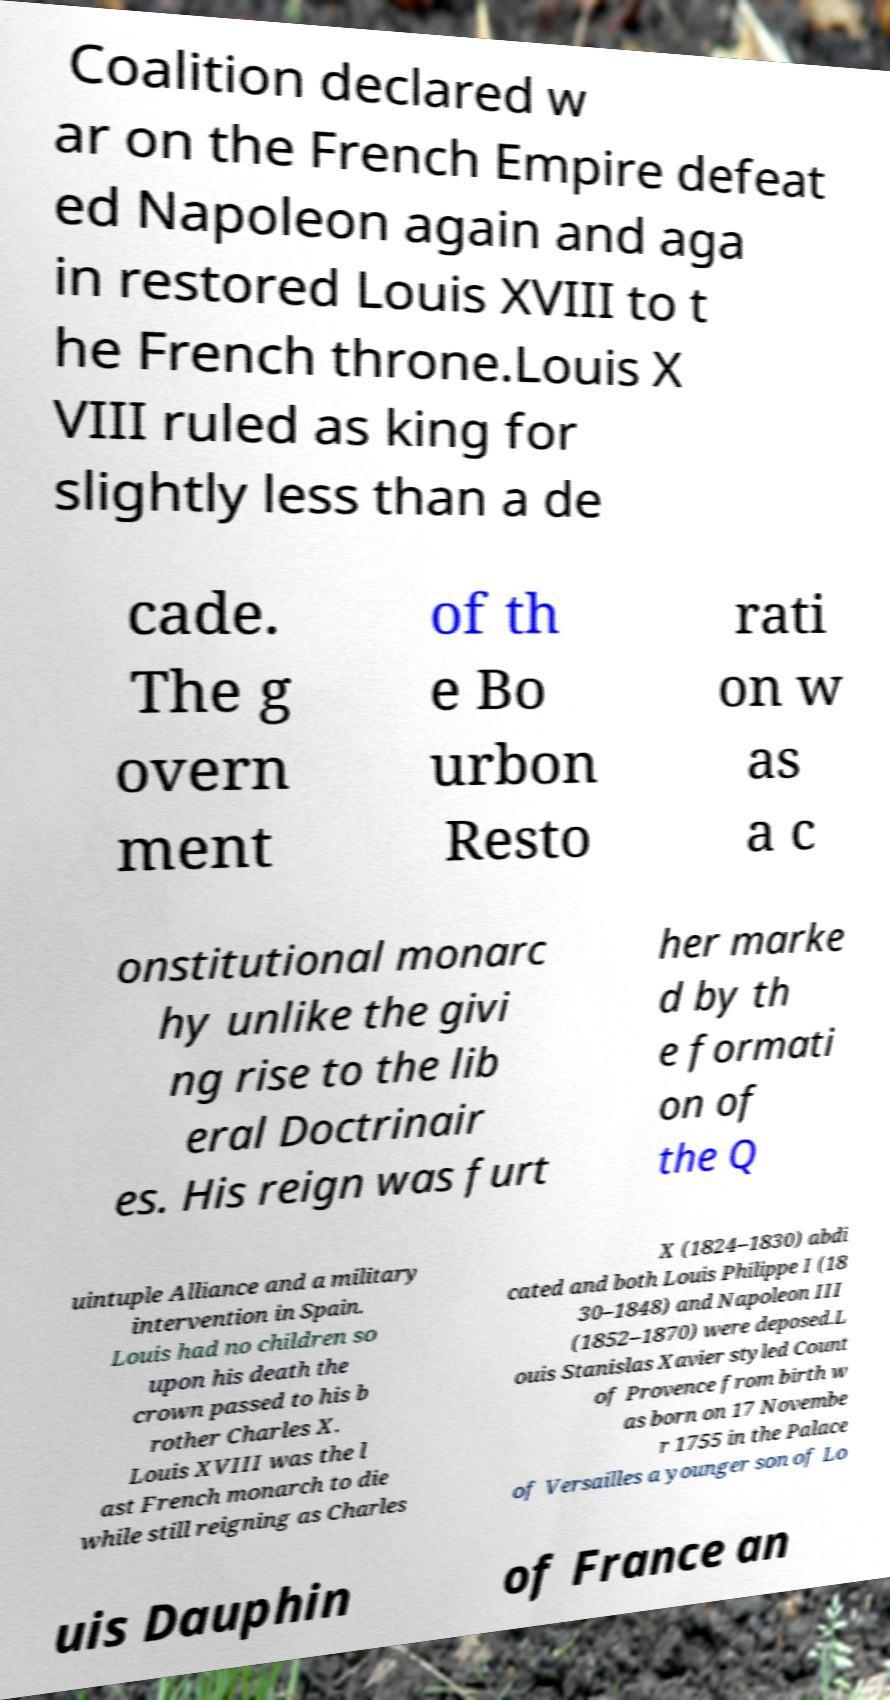Can you accurately transcribe the text from the provided image for me? Coalition declared w ar on the French Empire defeat ed Napoleon again and aga in restored Louis XVIII to t he French throne.Louis X VIII ruled as king for slightly less than a de cade. The g overn ment of th e Bo urbon Resto rati on w as a c onstitutional monarc hy unlike the givi ng rise to the lib eral Doctrinair es. His reign was furt her marke d by th e formati on of the Q uintuple Alliance and a military intervention in Spain. Louis had no children so upon his death the crown passed to his b rother Charles X. Louis XVIII was the l ast French monarch to die while still reigning as Charles X (1824–1830) abdi cated and both Louis Philippe I (18 30–1848) and Napoleon III (1852–1870) were deposed.L ouis Stanislas Xavier styled Count of Provence from birth w as born on 17 Novembe r 1755 in the Palace of Versailles a younger son of Lo uis Dauphin of France an 